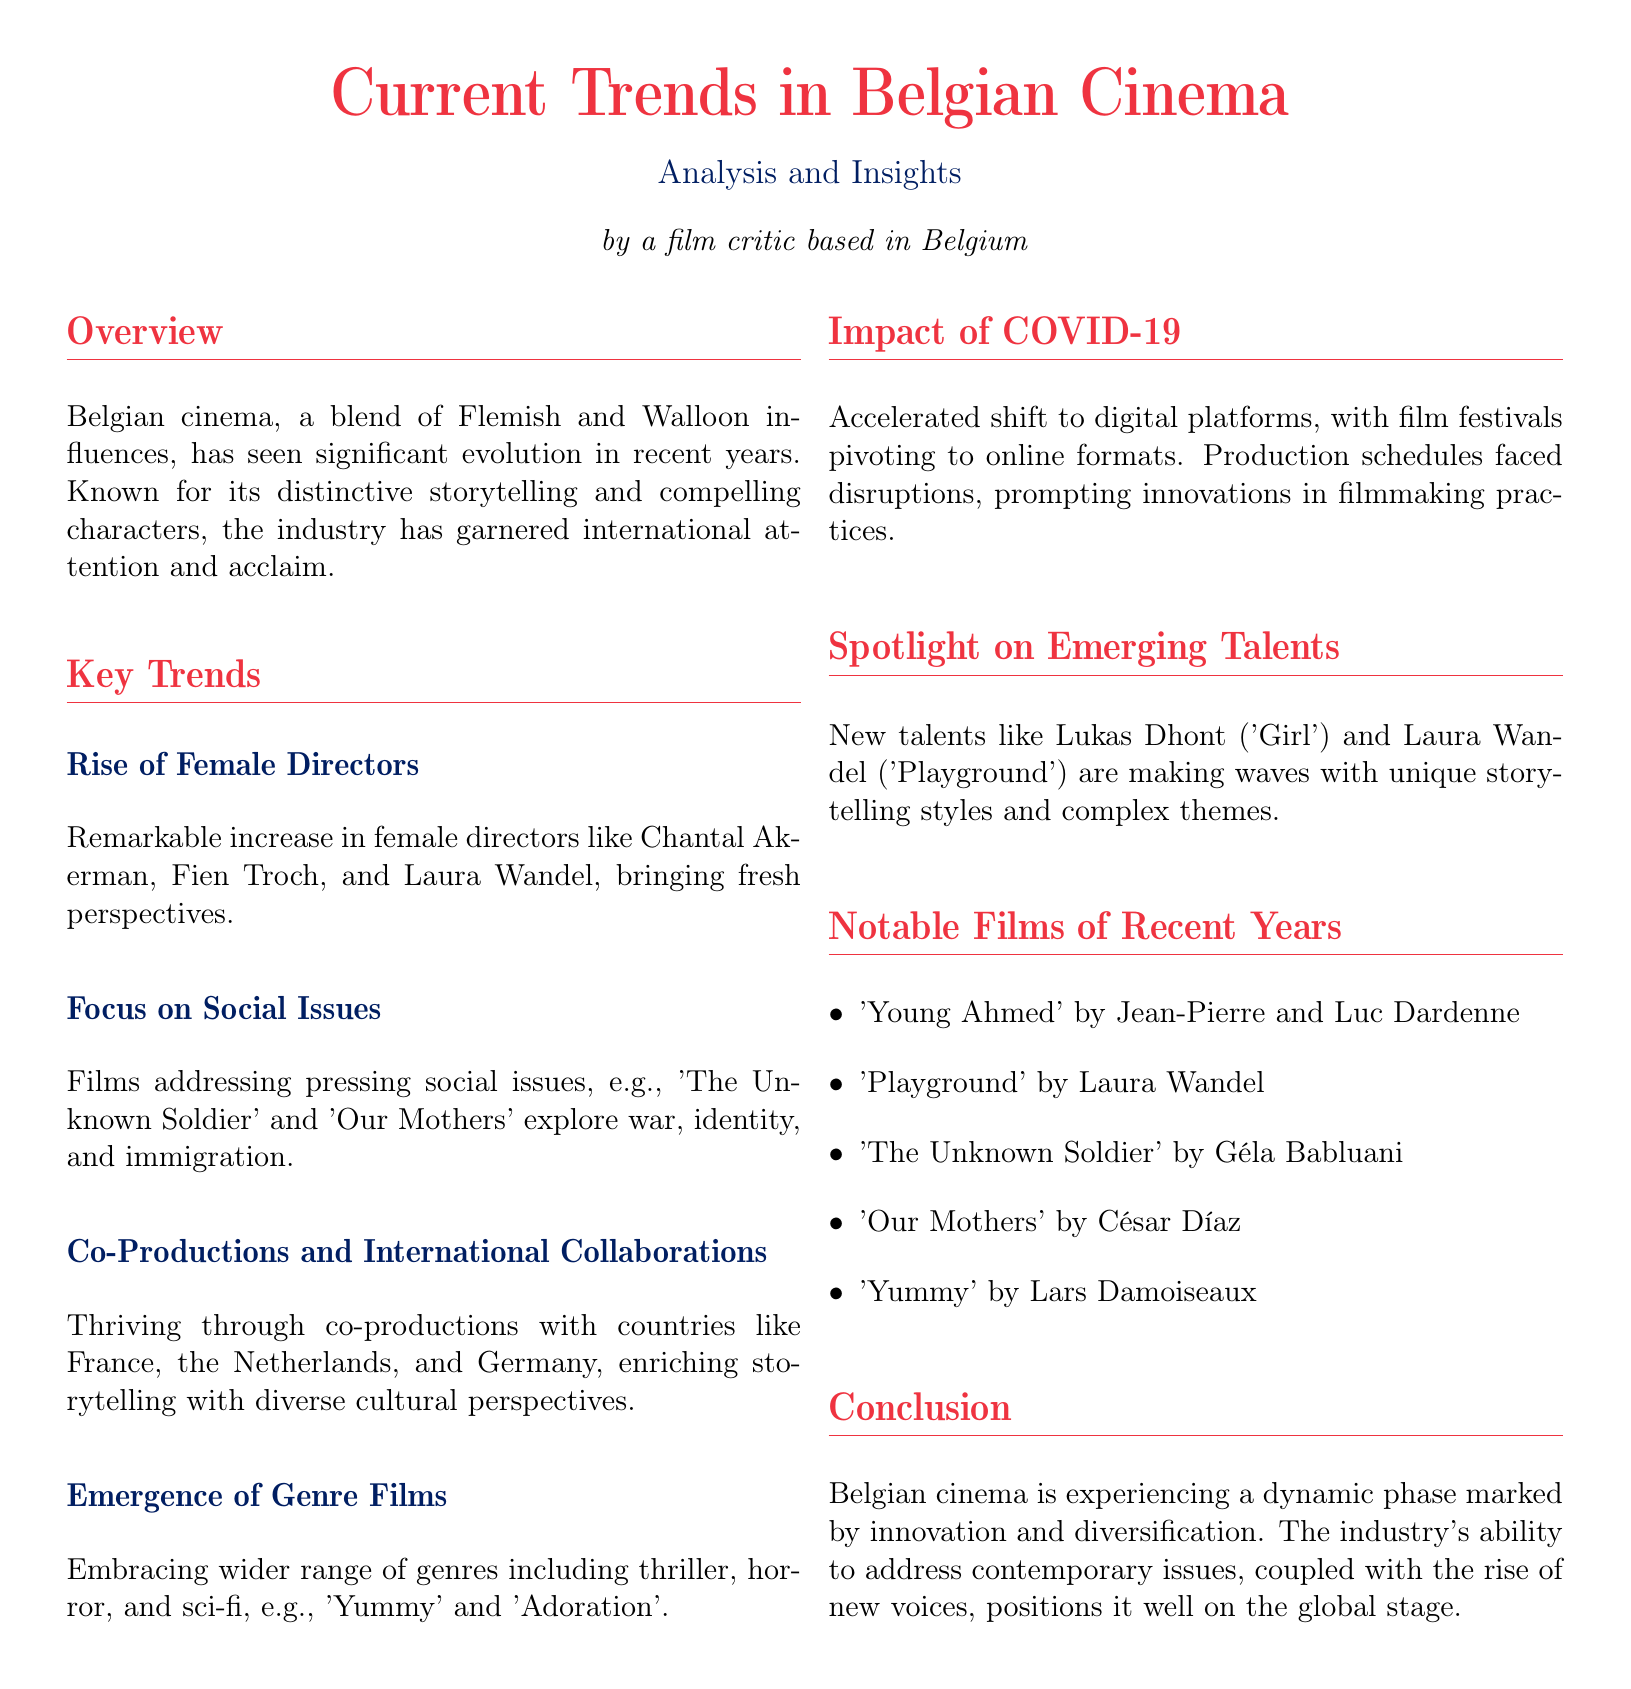What are the two main influences on Belgian cinema? The two main influences are Flemish and Walloon.
Answer: Flemish and Walloon Who is a notable female director mentioned in the document? The document mentions several notable female directors, including Chantal Akerman.
Answer: Chantal Akerman What type of films is Belgian cinema embracing according to the trends? The trends highlight that Belgian cinema is embracing a wider range of genres.
Answer: A wider range of genres Which film addresses the issue of immigration? 'Our Mothers' is mentioned as addressing the issue of immigration.
Answer: Our Mothers What has been the impact of COVID-19 on Belgian cinema? The impact includes an accelerated shift to digital platforms.
Answer: Accelerated shift to digital platforms Name one of the emerging talents in Belgian cinema. Lukas Dhont is one of the emerging talents mentioned in the document.
Answer: Lukas Dhont What genre is the film 'Yummy'? 'Yummy' is identified as a horror film.
Answer: Horror Which two countries are involved in co-productions with Belgium? Co-productions with France and the Netherlands are highlighted.
Answer: France and the Netherlands What year is cited in the context of films made by new talents? The document discusses recent years, without specifying a numeric year.
Answer: Recent years 